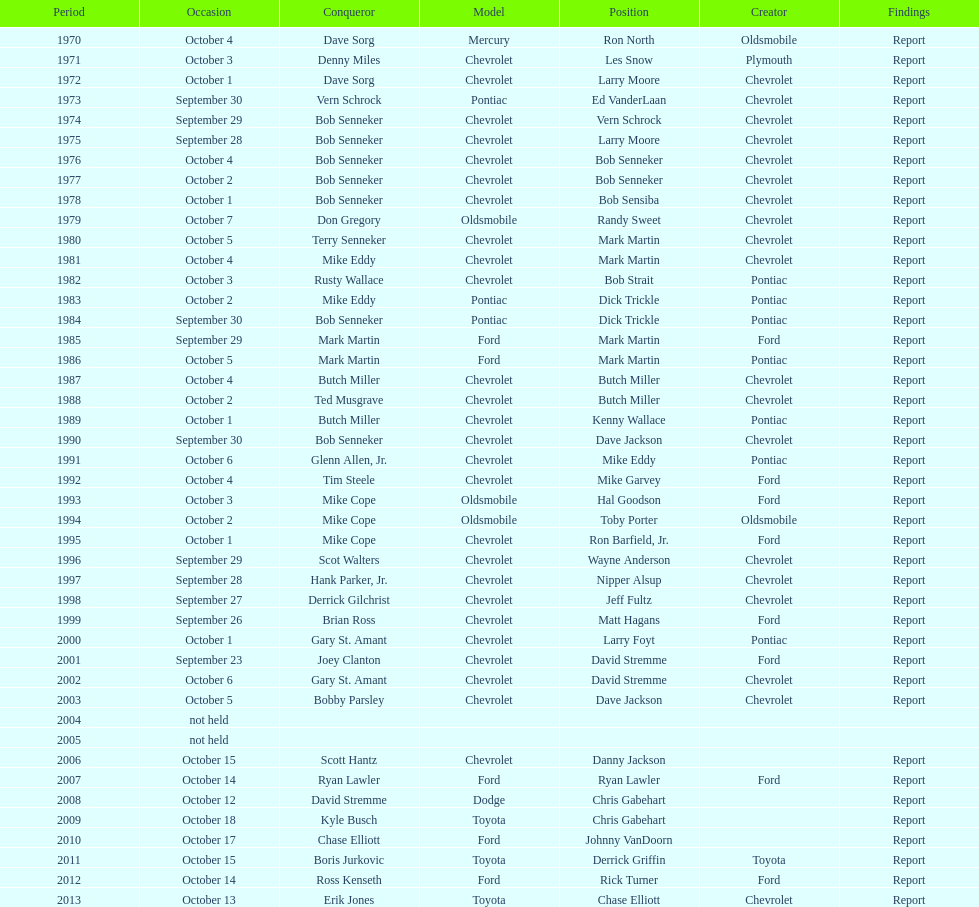Who on the list has the highest number of consecutive wins? Bob Senneker. 